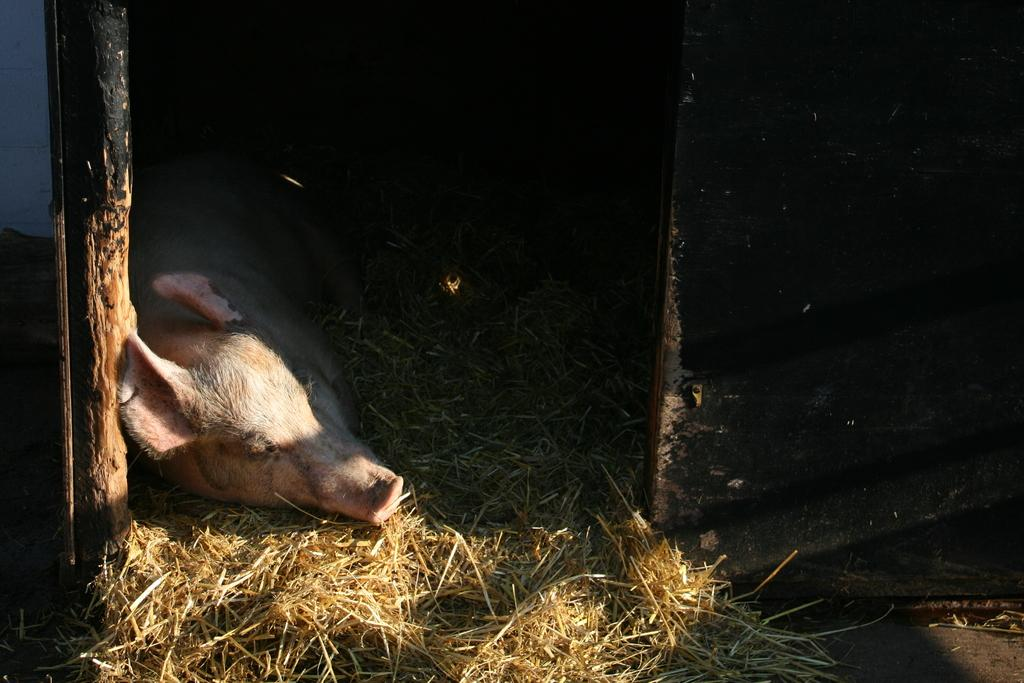What type of creature is present in the image? There is an animal in the image. Where is the animal located? The animal is on the grass. What other objects can be seen in the image? There are wooden poles in the image. What is the color of the background in the image? The background of the image is dark. What time of day is it in the image, considering the presence of cattle and houses? There is no indication of cattle or houses in the image, and therefore we cannot determine the time of day based on these elements. 